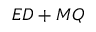Convert formula to latex. <formula><loc_0><loc_0><loc_500><loc_500>E D + M Q</formula> 